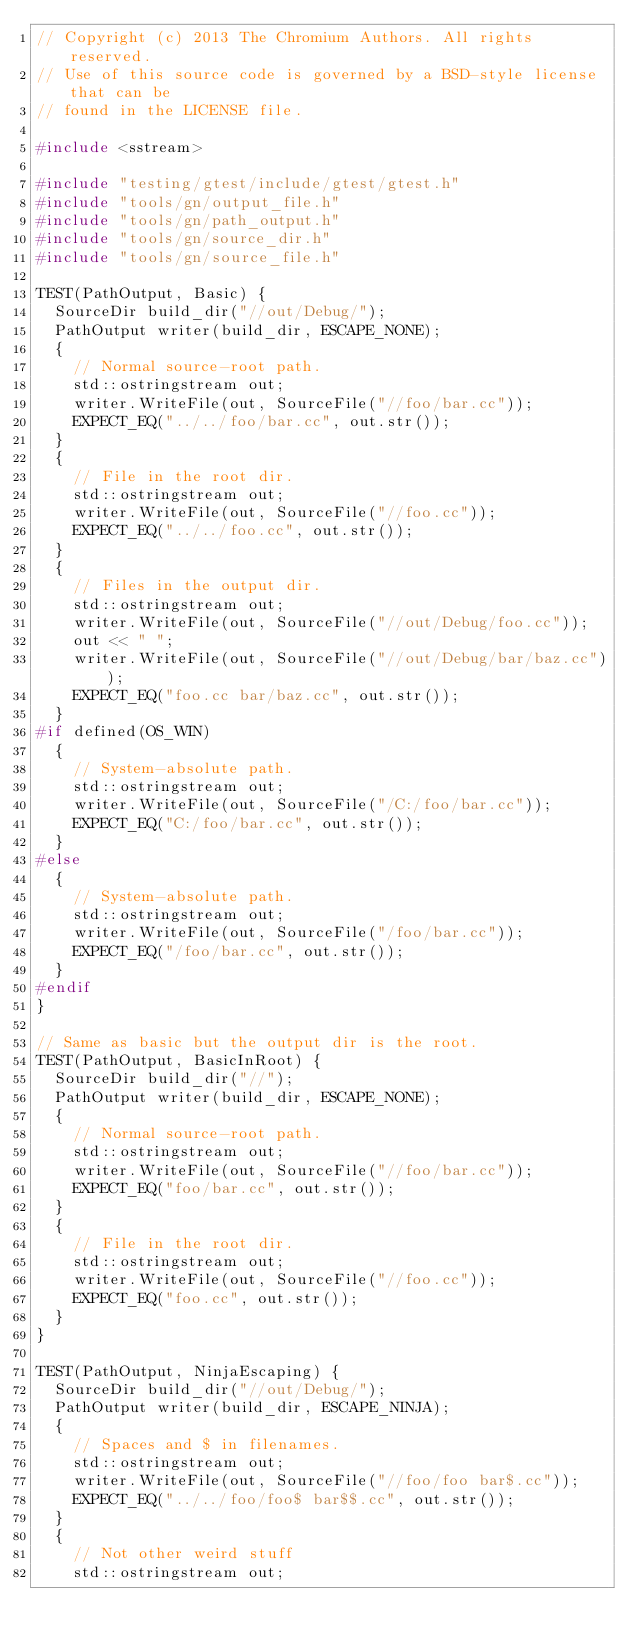<code> <loc_0><loc_0><loc_500><loc_500><_C++_>// Copyright (c) 2013 The Chromium Authors. All rights reserved.
// Use of this source code is governed by a BSD-style license that can be
// found in the LICENSE file.

#include <sstream>

#include "testing/gtest/include/gtest/gtest.h"
#include "tools/gn/output_file.h"
#include "tools/gn/path_output.h"
#include "tools/gn/source_dir.h"
#include "tools/gn/source_file.h"

TEST(PathOutput, Basic) {
  SourceDir build_dir("//out/Debug/");
  PathOutput writer(build_dir, ESCAPE_NONE);
  {
    // Normal source-root path.
    std::ostringstream out;
    writer.WriteFile(out, SourceFile("//foo/bar.cc"));
    EXPECT_EQ("../../foo/bar.cc", out.str());
  }
  {
    // File in the root dir.
    std::ostringstream out;
    writer.WriteFile(out, SourceFile("//foo.cc"));
    EXPECT_EQ("../../foo.cc", out.str());
  }
  {
    // Files in the output dir.
    std::ostringstream out;
    writer.WriteFile(out, SourceFile("//out/Debug/foo.cc"));
    out << " ";
    writer.WriteFile(out, SourceFile("//out/Debug/bar/baz.cc"));
    EXPECT_EQ("foo.cc bar/baz.cc", out.str());
  }
#if defined(OS_WIN)
  {
    // System-absolute path.
    std::ostringstream out;
    writer.WriteFile(out, SourceFile("/C:/foo/bar.cc"));
    EXPECT_EQ("C:/foo/bar.cc", out.str());
  }
#else
  {
    // System-absolute path.
    std::ostringstream out;
    writer.WriteFile(out, SourceFile("/foo/bar.cc"));
    EXPECT_EQ("/foo/bar.cc", out.str());
  }
#endif
}

// Same as basic but the output dir is the root.
TEST(PathOutput, BasicInRoot) {
  SourceDir build_dir("//");
  PathOutput writer(build_dir, ESCAPE_NONE);
  {
    // Normal source-root path.
    std::ostringstream out;
    writer.WriteFile(out, SourceFile("//foo/bar.cc"));
    EXPECT_EQ("foo/bar.cc", out.str());
  }
  {
    // File in the root dir.
    std::ostringstream out;
    writer.WriteFile(out, SourceFile("//foo.cc"));
    EXPECT_EQ("foo.cc", out.str());
  }
}

TEST(PathOutput, NinjaEscaping) {
  SourceDir build_dir("//out/Debug/");
  PathOutput writer(build_dir, ESCAPE_NINJA);
  {
    // Spaces and $ in filenames.
    std::ostringstream out;
    writer.WriteFile(out, SourceFile("//foo/foo bar$.cc"));
    EXPECT_EQ("../../foo/foo$ bar$$.cc", out.str());
  }
  {
    // Not other weird stuff
    std::ostringstream out;</code> 